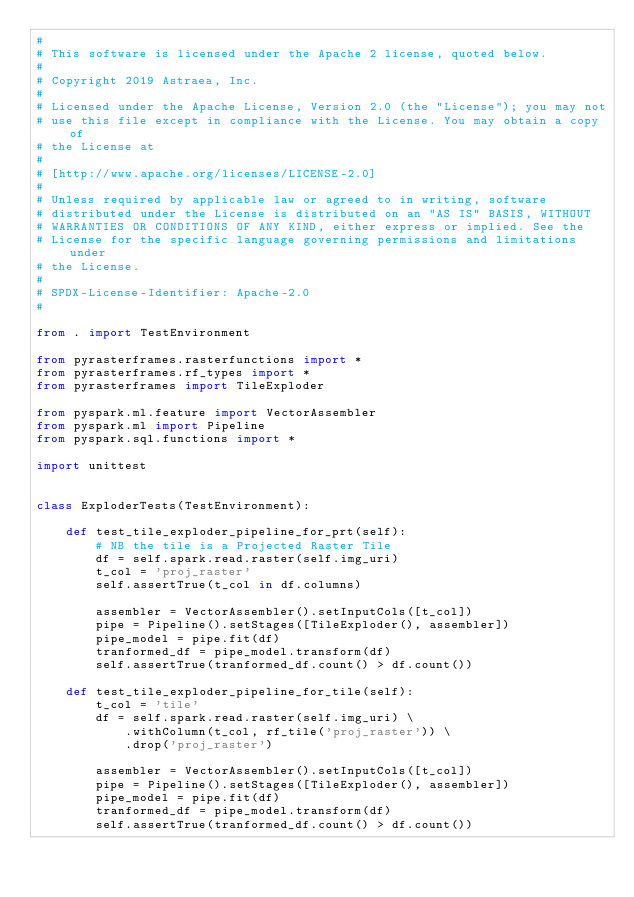Convert code to text. <code><loc_0><loc_0><loc_500><loc_500><_Python_>#
# This software is licensed under the Apache 2 license, quoted below.
#
# Copyright 2019 Astraea, Inc.
#
# Licensed under the Apache License, Version 2.0 (the "License"); you may not
# use this file except in compliance with the License. You may obtain a copy of
# the License at
#
# [http://www.apache.org/licenses/LICENSE-2.0]
#
# Unless required by applicable law or agreed to in writing, software
# distributed under the License is distributed on an "AS IS" BASIS, WITHOUT
# WARRANTIES OR CONDITIONS OF ANY KIND, either express or implied. See the
# License for the specific language governing permissions and limitations under
# the License.
#
# SPDX-License-Identifier: Apache-2.0
#

from . import TestEnvironment

from pyrasterframes.rasterfunctions import *
from pyrasterframes.rf_types import *
from pyrasterframes import TileExploder

from pyspark.ml.feature import VectorAssembler
from pyspark.ml import Pipeline
from pyspark.sql.functions import *

import unittest


class ExploderTests(TestEnvironment):

    def test_tile_exploder_pipeline_for_prt(self):
        # NB the tile is a Projected Raster Tile
        df = self.spark.read.raster(self.img_uri)
        t_col = 'proj_raster'
        self.assertTrue(t_col in df.columns)

        assembler = VectorAssembler().setInputCols([t_col])
        pipe = Pipeline().setStages([TileExploder(), assembler])
        pipe_model = pipe.fit(df)
        tranformed_df = pipe_model.transform(df)
        self.assertTrue(tranformed_df.count() > df.count())

    def test_tile_exploder_pipeline_for_tile(self):
        t_col = 'tile'
        df = self.spark.read.raster(self.img_uri) \
            .withColumn(t_col, rf_tile('proj_raster')) \
            .drop('proj_raster')

        assembler = VectorAssembler().setInputCols([t_col])
        pipe = Pipeline().setStages([TileExploder(), assembler])
        pipe_model = pipe.fit(df)
        tranformed_df = pipe_model.transform(df)
        self.assertTrue(tranformed_df.count() > df.count())
</code> 